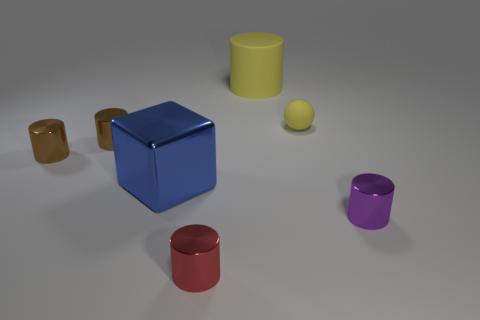There is a big thing on the left side of the tiny metallic object that is in front of the tiny metallic object that is right of the matte cylinder; what is it made of?
Give a very brief answer. Metal. Are there more red things than large cyan cylinders?
Offer a terse response. Yes. Is there anything else of the same color as the big metal block?
Ensure brevity in your answer.  No. There is a red cylinder that is the same material as the large cube; what size is it?
Offer a very short reply. Small. What is the material of the tiny purple object?
Ensure brevity in your answer.  Metal. What number of metal things are the same size as the red metallic cylinder?
Offer a terse response. 3. There is a matte thing that is the same color as the rubber sphere; what is its shape?
Keep it short and to the point. Cylinder. Are there any other large cyan matte things that have the same shape as the large matte thing?
Offer a terse response. No. What color is the matte thing that is the same size as the red metal cylinder?
Your answer should be very brief. Yellow. There is a metallic cylinder that is right of the yellow matte object on the left side of the tiny matte thing; what is its color?
Your answer should be compact. Purple. 